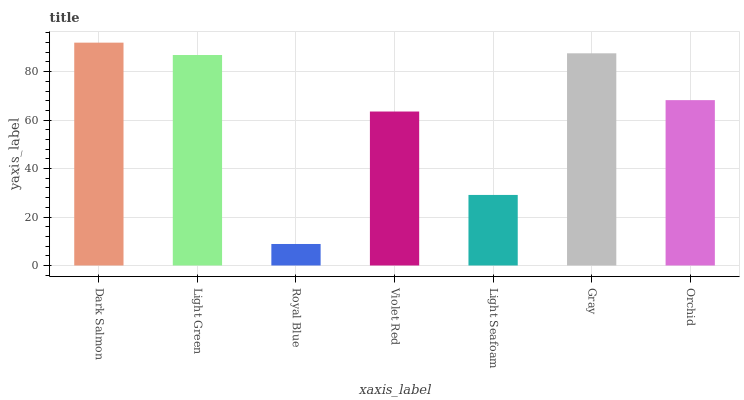Is Royal Blue the minimum?
Answer yes or no. Yes. Is Dark Salmon the maximum?
Answer yes or no. Yes. Is Light Green the minimum?
Answer yes or no. No. Is Light Green the maximum?
Answer yes or no. No. Is Dark Salmon greater than Light Green?
Answer yes or no. Yes. Is Light Green less than Dark Salmon?
Answer yes or no. Yes. Is Light Green greater than Dark Salmon?
Answer yes or no. No. Is Dark Salmon less than Light Green?
Answer yes or no. No. Is Orchid the high median?
Answer yes or no. Yes. Is Orchid the low median?
Answer yes or no. Yes. Is Dark Salmon the high median?
Answer yes or no. No. Is Royal Blue the low median?
Answer yes or no. No. 